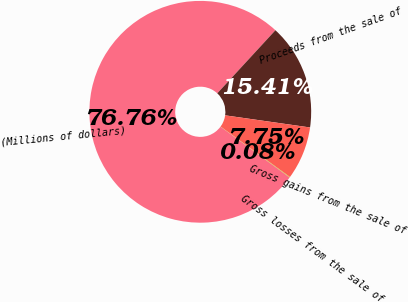Convert chart. <chart><loc_0><loc_0><loc_500><loc_500><pie_chart><fcel>(Millions of dollars)<fcel>Proceeds from the sale of<fcel>Gross gains from the sale of<fcel>Gross losses from the sale of<nl><fcel>76.76%<fcel>15.41%<fcel>7.75%<fcel>0.08%<nl></chart> 